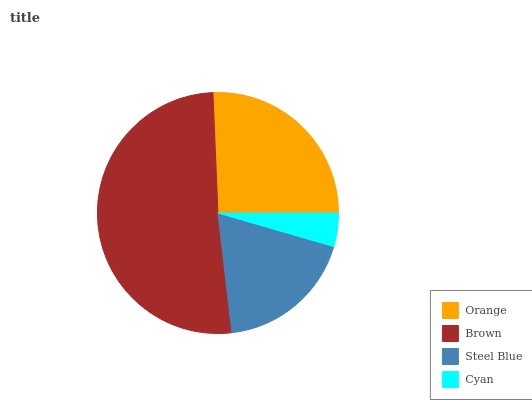Is Cyan the minimum?
Answer yes or no. Yes. Is Brown the maximum?
Answer yes or no. Yes. Is Steel Blue the minimum?
Answer yes or no. No. Is Steel Blue the maximum?
Answer yes or no. No. Is Brown greater than Steel Blue?
Answer yes or no. Yes. Is Steel Blue less than Brown?
Answer yes or no. Yes. Is Steel Blue greater than Brown?
Answer yes or no. No. Is Brown less than Steel Blue?
Answer yes or no. No. Is Orange the high median?
Answer yes or no. Yes. Is Steel Blue the low median?
Answer yes or no. Yes. Is Steel Blue the high median?
Answer yes or no. No. Is Orange the low median?
Answer yes or no. No. 